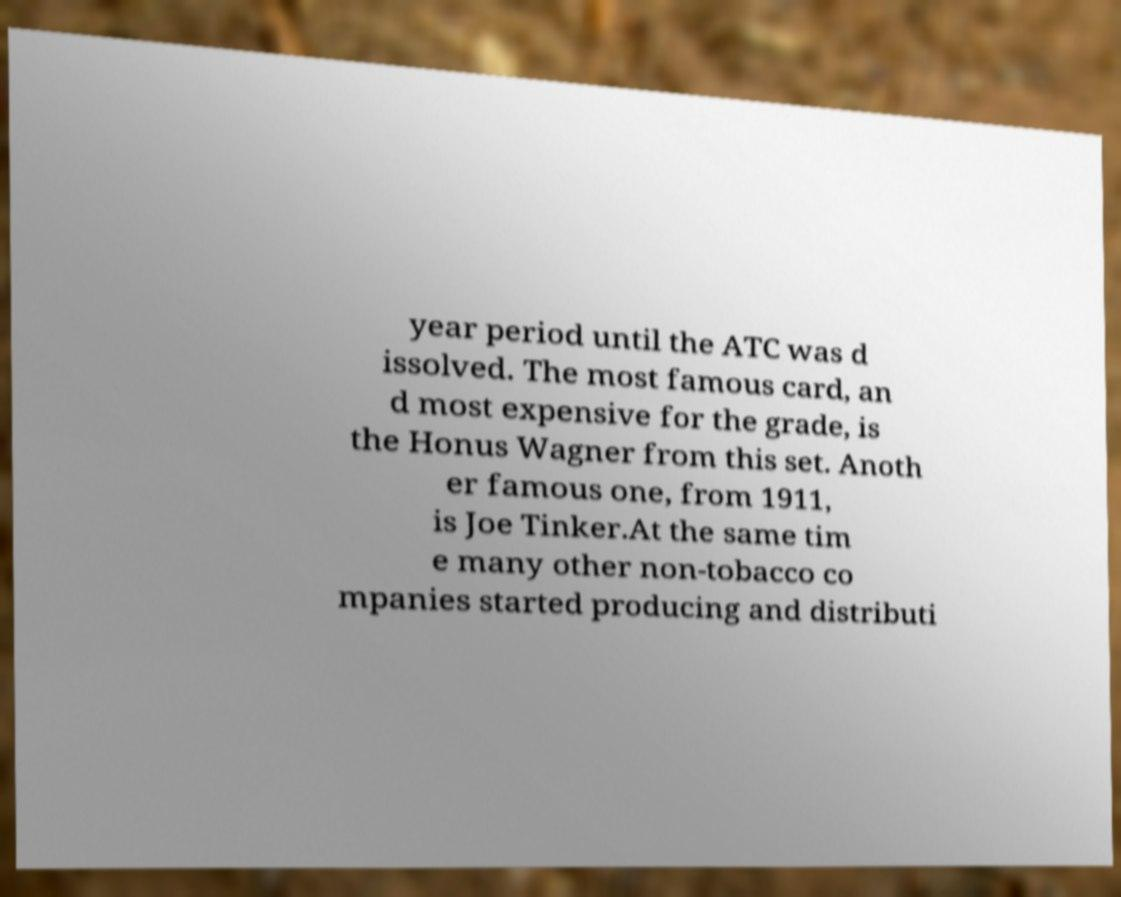There's text embedded in this image that I need extracted. Can you transcribe it verbatim? year period until the ATC was d issolved. The most famous card, an d most expensive for the grade, is the Honus Wagner from this set. Anoth er famous one, from 1911, is Joe Tinker.At the same tim e many other non-tobacco co mpanies started producing and distributi 